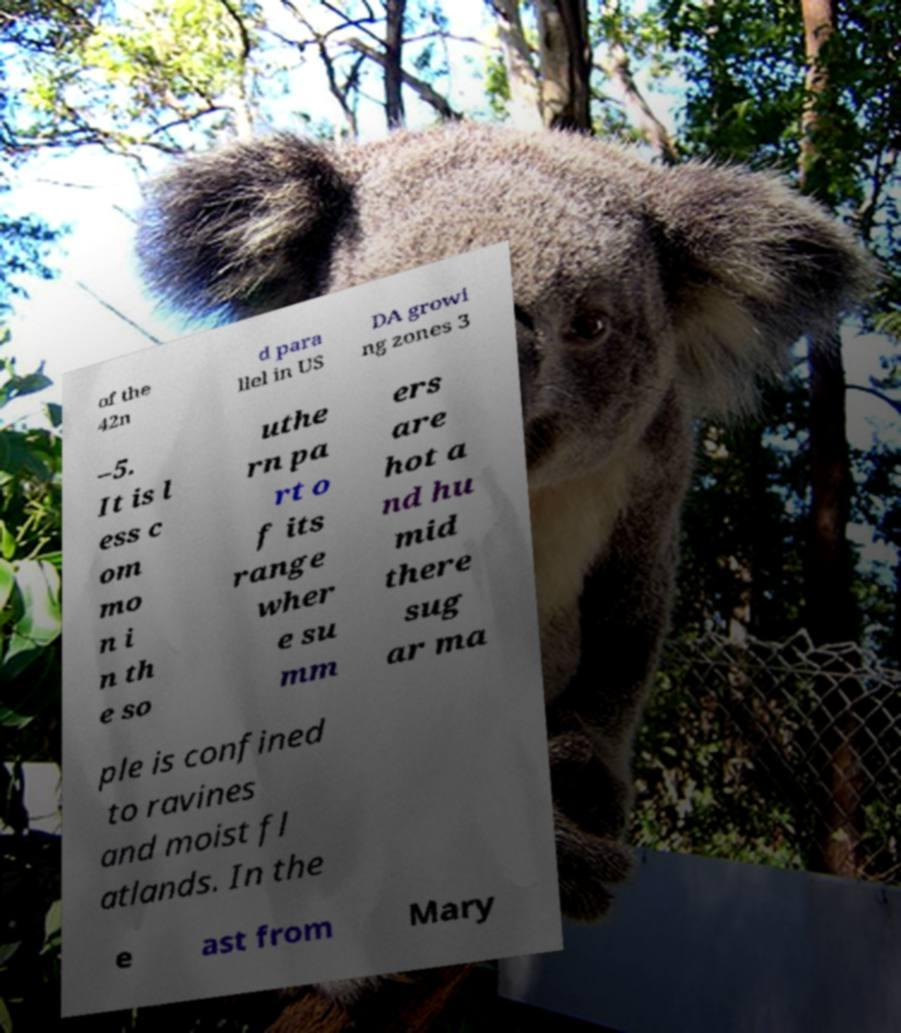For documentation purposes, I need the text within this image transcribed. Could you provide that? of the 42n d para llel in US DA growi ng zones 3 –5. It is l ess c om mo n i n th e so uthe rn pa rt o f its range wher e su mm ers are hot a nd hu mid there sug ar ma ple is confined to ravines and moist fl atlands. In the e ast from Mary 